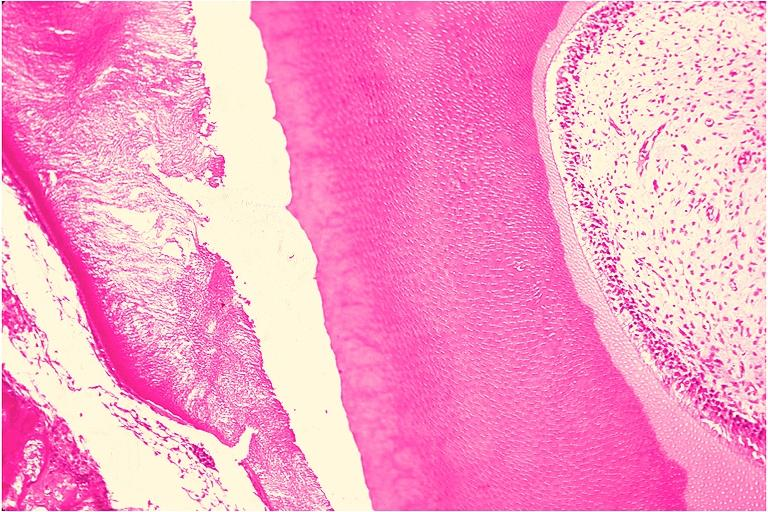what is present?
Answer the question using a single word or phrase. Oral 